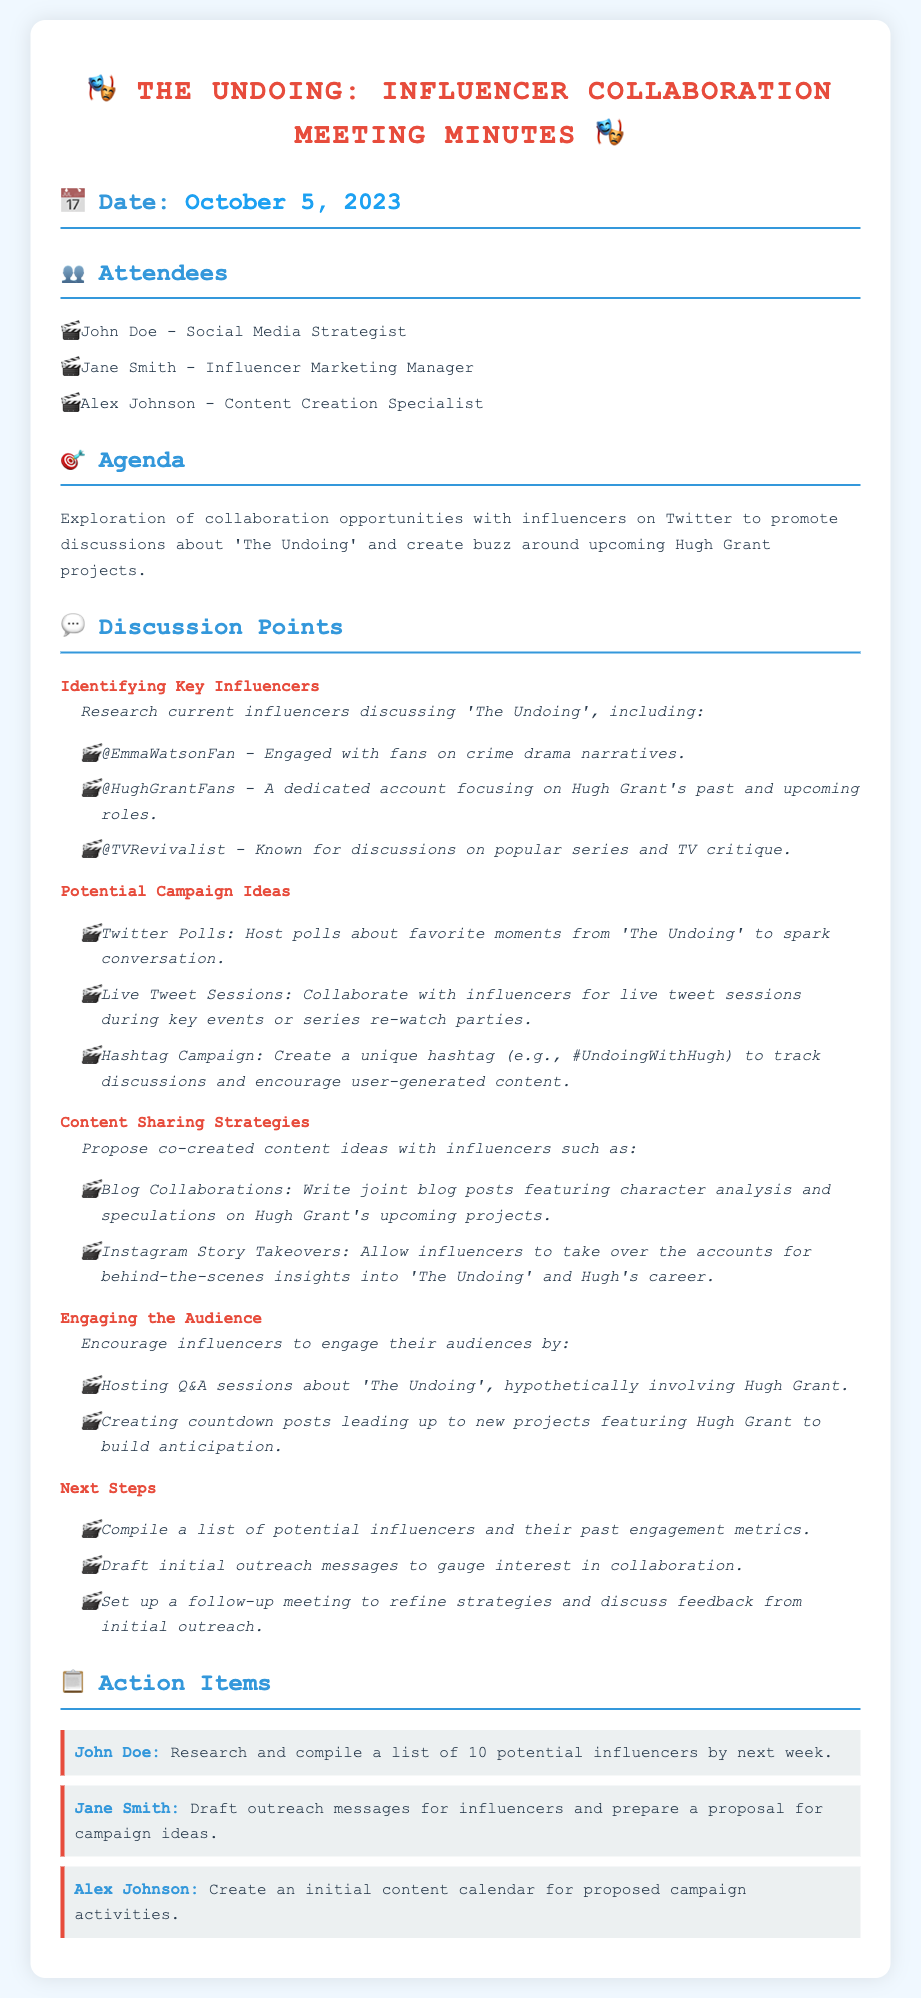What was the date of the meeting? The date of the meeting is explicitly mentioned in the document, which is October 5, 2023.
Answer: October 5, 2023 Who were the attendees of the meeting? The document lists specific individuals who attended the meeting along with their roles, including John Doe, Jane Smith, and Alex Johnson.
Answer: John Doe, Jane Smith, Alex Johnson What is the main agenda of the meeting? The agenda outlines the primary focus of the discussion, which is collaboration with influencers on Twitter regarding 'The Undoing' and Hugh Grant projects.
Answer: Collaboration opportunities with influencers What social media campaign idea involves user engagement? One of the discussed campaign ideas includes hosting Twitter polls to increase engagement among fans of 'The Undoing'.
Answer: Twitter Polls What is one proposed content sharing strategy mentioned in the meeting? The meeting minutes describe several strategies, including joint blog posts featuring character analysis about 'The Undoing' and Hugh Grant.
Answer: Blog Collaborations How many action items were assigned in the meeting? The document lists three distinct action items assigned to different individuals after the meeting.
Answer: Three Which influencer is focused on discussions about Hugh Grant? The document specifically mentions an account dedicated to Hugh Grant updates.
Answer: @HughGrantFans What is the proposed unique hashtag for the campaign? A unique hashtag is mentioned for tracking discussions related to 'The Undoing' and Hugh Grant.
Answer: #UndoingWithHugh 